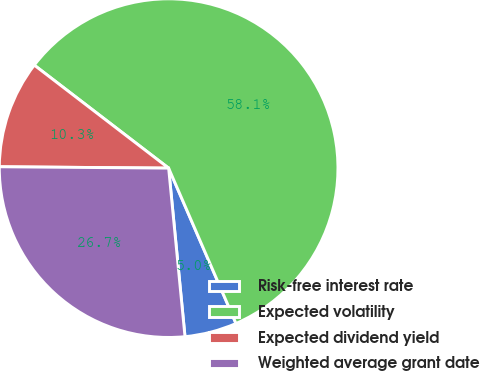Convert chart. <chart><loc_0><loc_0><loc_500><loc_500><pie_chart><fcel>Risk-free interest rate<fcel>Expected volatility<fcel>Expected dividend yield<fcel>Weighted average grant date<nl><fcel>4.97%<fcel>58.08%<fcel>10.28%<fcel>26.67%<nl></chart> 